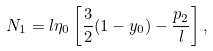Convert formula to latex. <formula><loc_0><loc_0><loc_500><loc_500>N _ { 1 } = l \eta _ { 0 } \left [ \frac { 3 } { 2 } ( 1 - y _ { 0 } ) - \frac { p _ { 2 } } { l } \right ] ,</formula> 